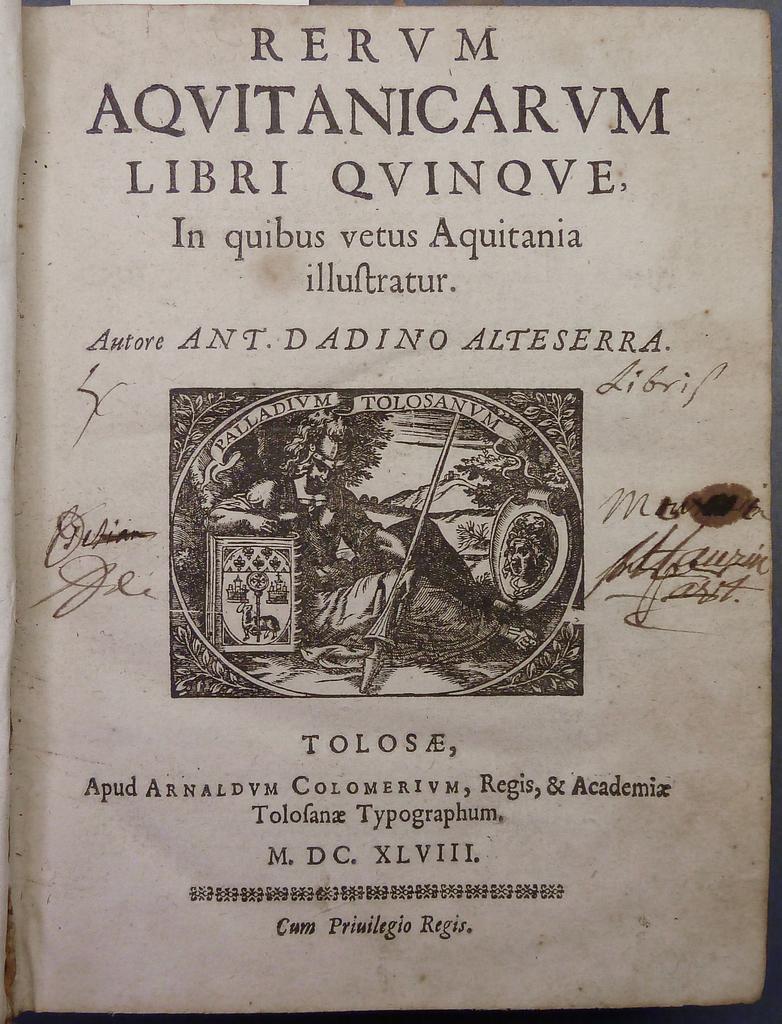Who wrote this piece?
Ensure brevity in your answer.  Ant. dadino alteserra. What is the name of the book?
Ensure brevity in your answer.  Aqvitanicarvm. 